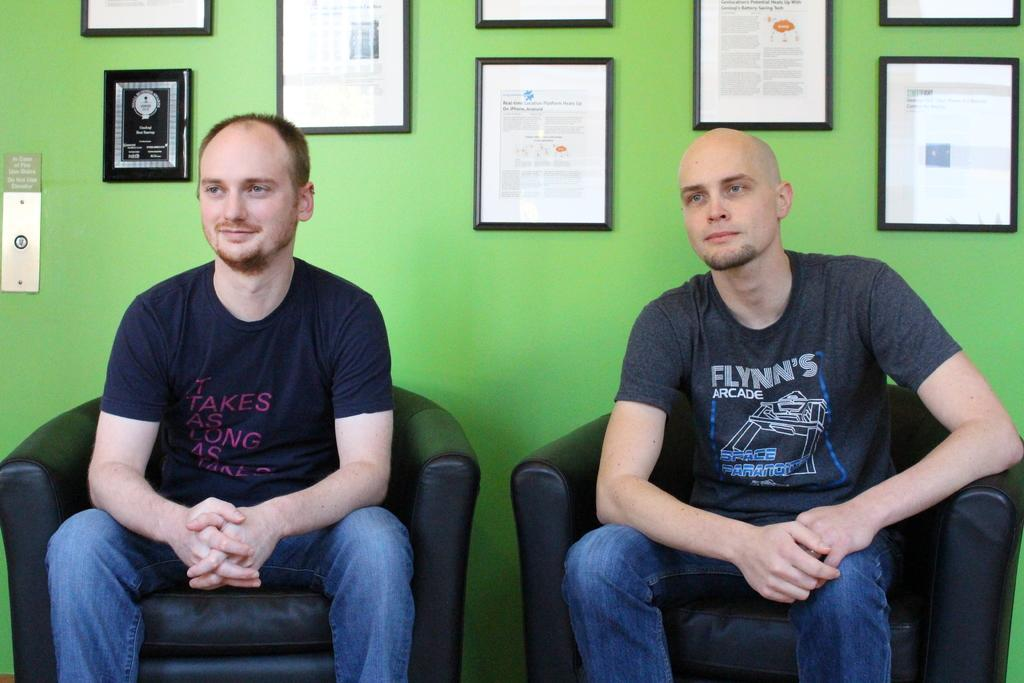How many people are in the image? There are 2 people in the image. What are the people sitting on? The people are sitting on black sofa chairs. What are the people wearing? The people are wearing black t-shirts and jeans. What can be seen in the background of the image? There is a green wall in the background with many photo frames. Can you see any fog in the image? There is no fog present in the image. Are the people on a ship in the image? There is no ship present in the image; the people are sitting on black sofa chairs. 